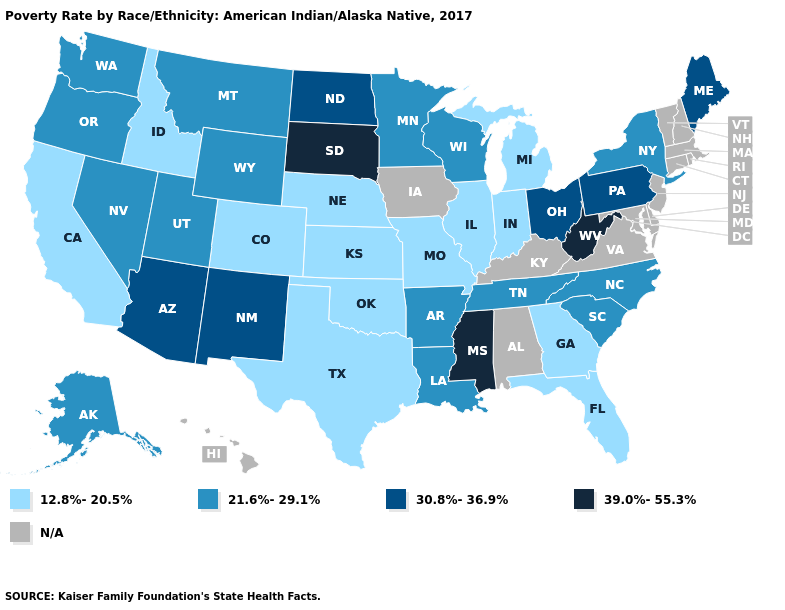Name the states that have a value in the range 39.0%-55.3%?
Short answer required. Mississippi, South Dakota, West Virginia. Name the states that have a value in the range N/A?
Answer briefly. Alabama, Connecticut, Delaware, Hawaii, Iowa, Kentucky, Maryland, Massachusetts, New Hampshire, New Jersey, Rhode Island, Vermont, Virginia. Does the map have missing data?
Keep it brief. Yes. Name the states that have a value in the range 39.0%-55.3%?
Quick response, please. Mississippi, South Dakota, West Virginia. Which states have the highest value in the USA?
Keep it brief. Mississippi, South Dakota, West Virginia. Does Oklahoma have the highest value in the USA?
Quick response, please. No. Which states have the lowest value in the South?
Short answer required. Florida, Georgia, Oklahoma, Texas. What is the value of Alaska?
Concise answer only. 21.6%-29.1%. Does the first symbol in the legend represent the smallest category?
Keep it brief. Yes. What is the value of Idaho?
Write a very short answer. 12.8%-20.5%. Does South Dakota have the highest value in the MidWest?
Write a very short answer. Yes. What is the value of New Hampshire?
Short answer required. N/A. What is the lowest value in states that border South Dakota?
Quick response, please. 12.8%-20.5%. Name the states that have a value in the range 39.0%-55.3%?
Write a very short answer. Mississippi, South Dakota, West Virginia. 